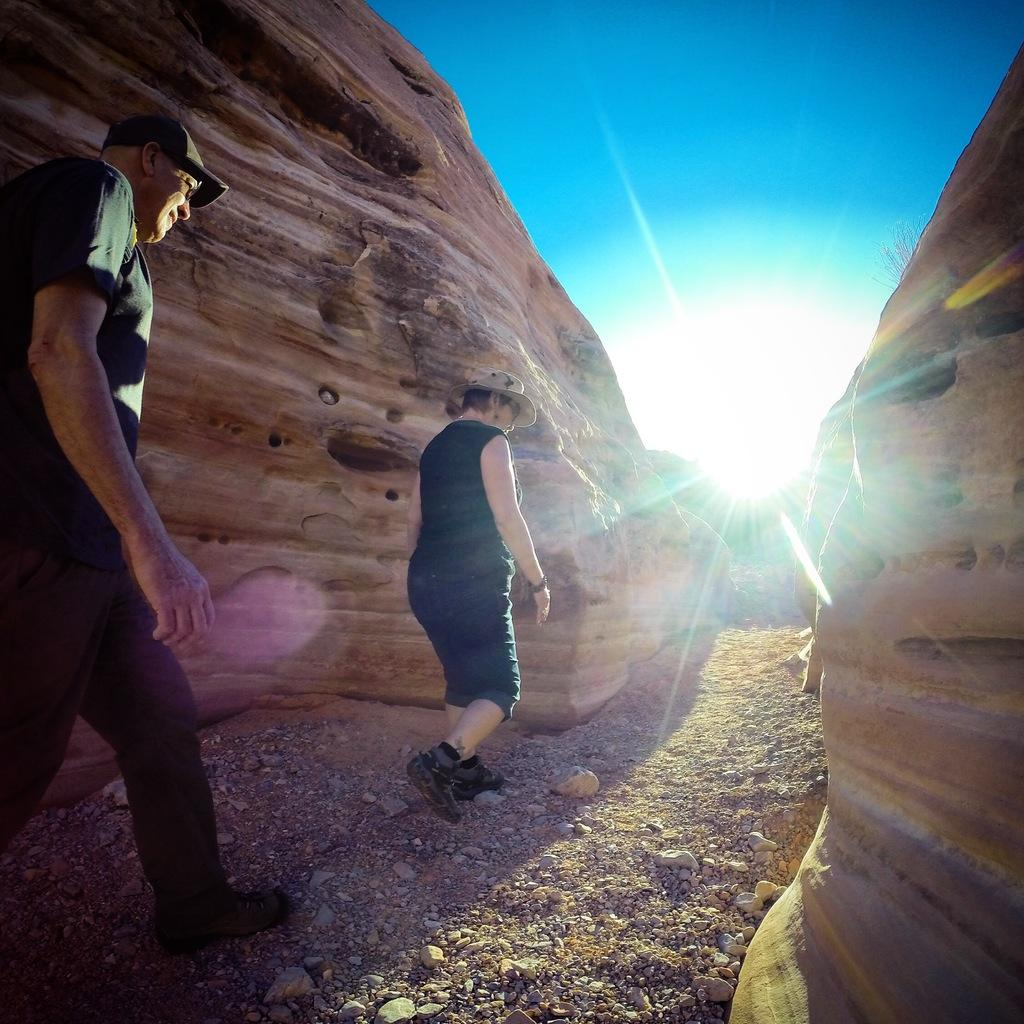How many people are in the image? There are two people in the image, a man and a lady. What are the man and lady wearing on their heads? The man is wearing a cap, and the lady is wearing a hat. What can be seen in the background of the image? There are rocks in the background of the image. What type of light is visible in the image? There is sunlight in the image. What is visible at the bottom of the image? There is ground visible at the bottom of the image. What type of butter is being used to paint the wall in the image? There is no wall or butter present in the image. How many eggs are visible in the image? There are no eggs visible in the image. 